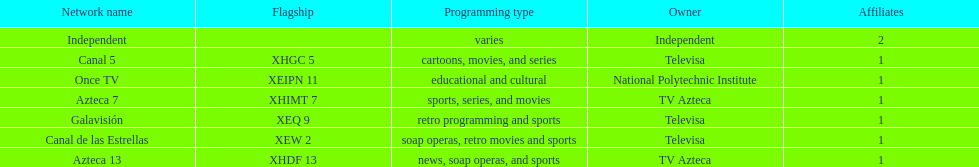How many networks do not air sports? 2. 